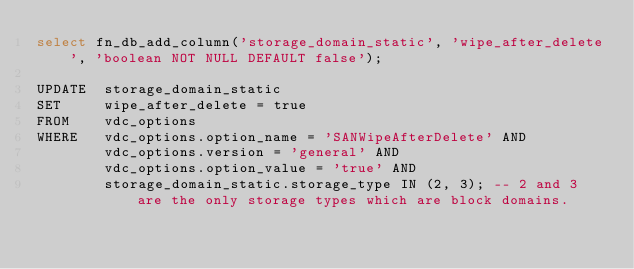Convert code to text. <code><loc_0><loc_0><loc_500><loc_500><_SQL_>select fn_db_add_column('storage_domain_static', 'wipe_after_delete', 'boolean NOT NULL DEFAULT false');

UPDATE  storage_domain_static
SET     wipe_after_delete = true
FROM    vdc_options
WHERE   vdc_options.option_name = 'SANWipeAfterDelete' AND
        vdc_options.version = 'general' AND
        vdc_options.option_value = 'true' AND
        storage_domain_static.storage_type IN (2, 3); -- 2 and 3 are the only storage types which are block domains.
</code> 